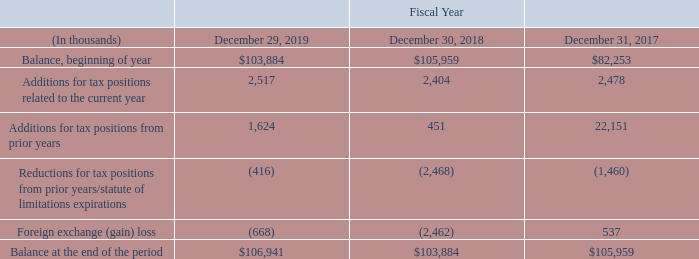Unrecognized Tax Benefits
Current accounting guidance contains a two-step approach to recognizing and measuring uncertain tax positions. The first step is to evaluate the tax position for recognition by determining if the weight of available evidence indicates that it is more likely than not that the position will be sustained on audit, including resolution of related appeals or litigation processes, if any. The second step is to measure the tax benefit as the largest amount that is more than 50% likely of being realized upon ultimate settlement.
A reconciliation of the beginning and ending amounts of unrecognized tax benefits during fiscal 2019, 2018, and 2017 is as follows:
Included in the unrecognized tax benefits at fiscal 2019 and 2018 is $38.2 million and $36.7 million, respectively, that if recognized, would result in a reduction of our effective tax rate. The amounts differ from the long-term liability recorded of $20.1 million and $16.8 million as of fiscal 2019 and 2018, respectively, due to accrued interest and penalties, as well as unrecognized tax benefits of French and Italian entities that are recorded against deferred tax asset balances without valuation allowance.
We believe that events that could occur in the next 12 months and cause a change in unrecognized tax benefits include, but are not limited to, the following: • commencement, continuation or completion of examinations of our tax returns by the U.S. or foreign taxing authorities; and • expiration of statutes of limitation on our tax returns.
The calculation of unrecognized tax benefits involves dealing with uncertainties in the application of complex global tax regulations. Uncertainties include, but are not limited to, the impact of legislative, regulatory and judicial developments, transfer pricing and the application of withholding taxes. We regularly assess our tax positions in light of legislative, bilateral tax treaty, regulatory and judicial developments in the countries in which we do business. We determined that an estimate of the range of reasonably possible change in the amounts of unrecognized tax benefits within the next 12 months cannot be made.
What would be the result if unrecognized tax benefits in 2019 and 2018 become recognized? Would result in a reduction of our effective tax rate. What events would cause a change in unrecognized tax benefits? Commencement, continuation or completion of examinations of our tax returns by the u.s. or foreign taxing authorities, expiration of statutes of limitation on our tax returns. What is the Balance, beginning of year for 2019?
Answer scale should be: thousand. 103,884. Which year was the balance in the beginning of the year the highest? $105,959 > $103,884 > $82,253
Answer: 2018. What was the change in long term liability from 2018 to 2019?
Answer scale should be: million. 20.1 million - 16.8 million 
Answer: 3.3. What was the percentage change of the balance at the end of the period from 2018 to 2019?
Answer scale should be: percent. ($106,941 - $103,884)/$103,884 
Answer: 2.94. 